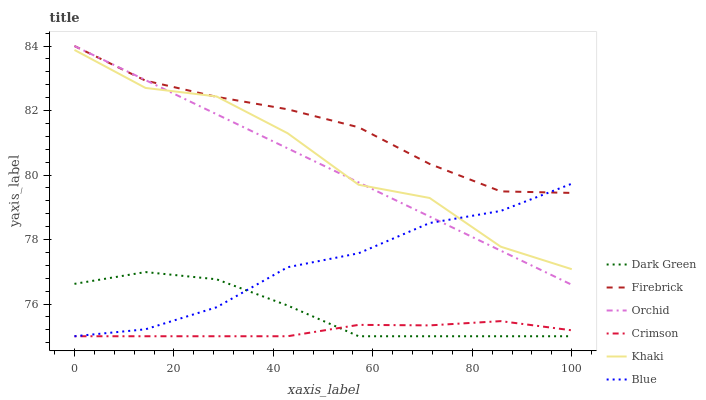Does Crimson have the minimum area under the curve?
Answer yes or no. Yes. Does Firebrick have the maximum area under the curve?
Answer yes or no. Yes. Does Khaki have the minimum area under the curve?
Answer yes or no. No. Does Khaki have the maximum area under the curve?
Answer yes or no. No. Is Orchid the smoothest?
Answer yes or no. Yes. Is Khaki the roughest?
Answer yes or no. Yes. Is Firebrick the smoothest?
Answer yes or no. No. Is Firebrick the roughest?
Answer yes or no. No. Does Blue have the lowest value?
Answer yes or no. Yes. Does Khaki have the lowest value?
Answer yes or no. No. Does Orchid have the highest value?
Answer yes or no. Yes. Does Khaki have the highest value?
Answer yes or no. No. Is Dark Green less than Khaki?
Answer yes or no. Yes. Is Firebrick greater than Crimson?
Answer yes or no. Yes. Does Blue intersect Firebrick?
Answer yes or no. Yes. Is Blue less than Firebrick?
Answer yes or no. No. Is Blue greater than Firebrick?
Answer yes or no. No. Does Dark Green intersect Khaki?
Answer yes or no. No. 